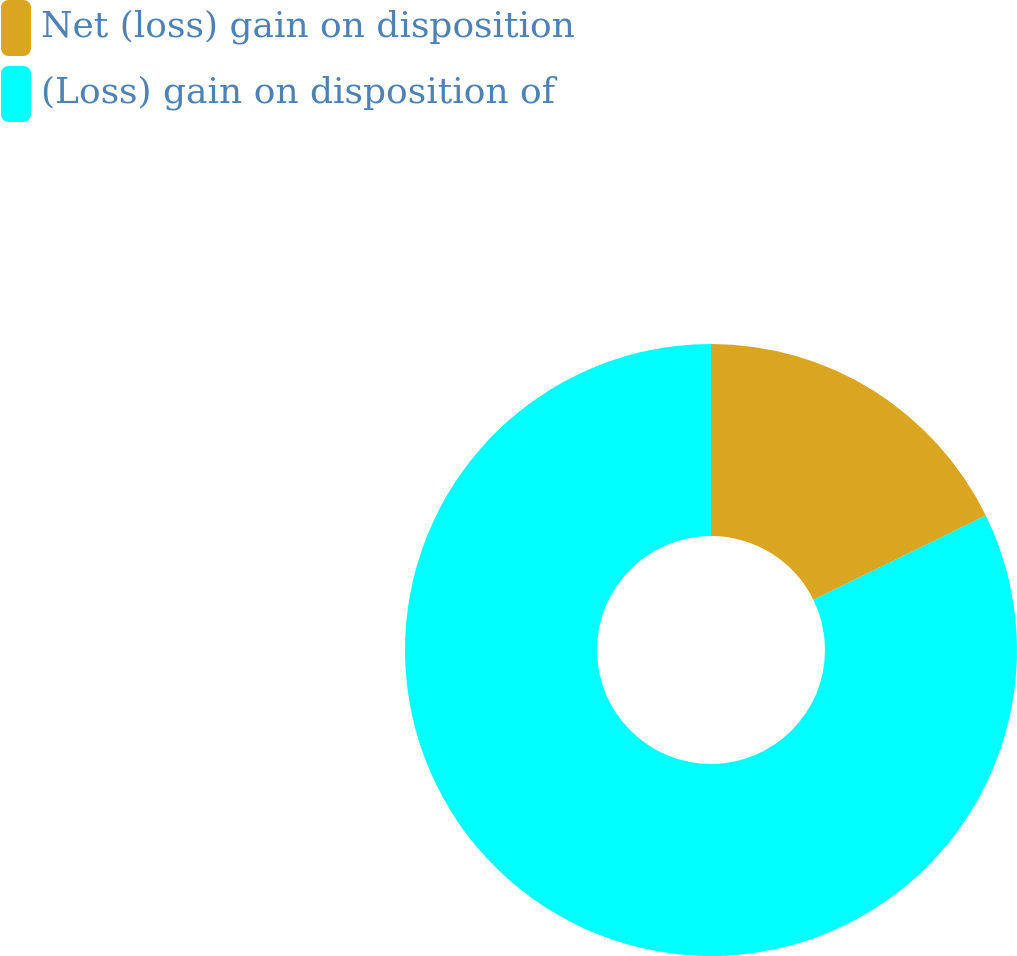Convert chart. <chart><loc_0><loc_0><loc_500><loc_500><pie_chart><fcel>Net (loss) gain on disposition<fcel>(Loss) gain on disposition of<nl><fcel>17.75%<fcel>82.25%<nl></chart> 